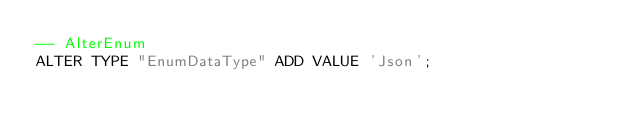<code> <loc_0><loc_0><loc_500><loc_500><_SQL_>-- AlterEnum
ALTER TYPE "EnumDataType" ADD VALUE 'Json';
</code> 